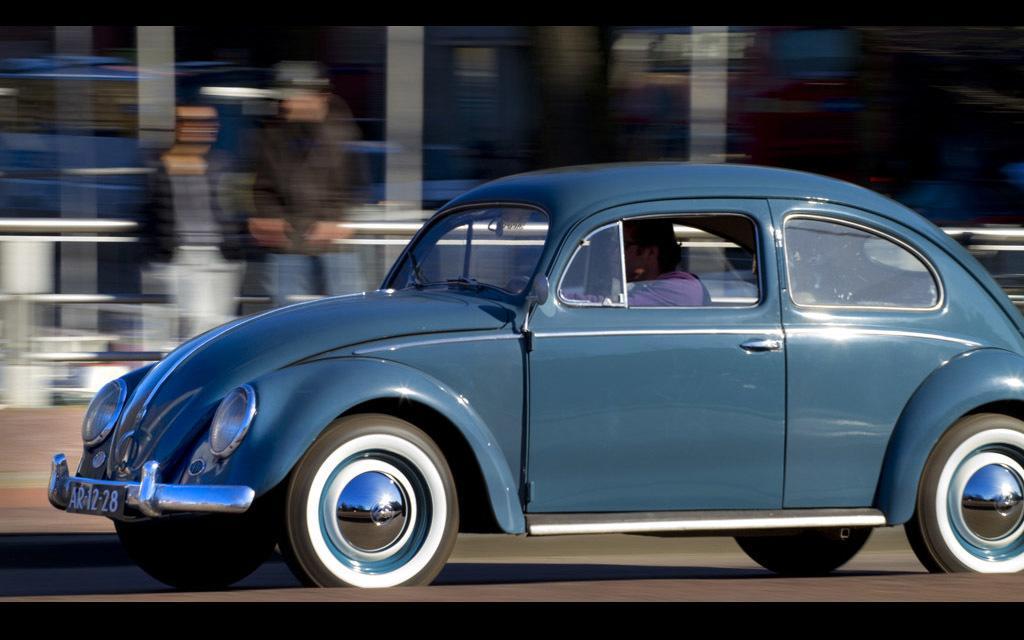How would you summarize this image in a sentence or two? This picture is taken outside a road. in the road a blue car a passing by. Inside it there is a person. In the background there are two persons. The background is hazy. 